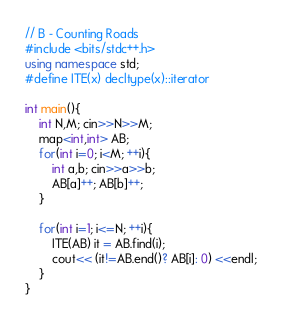Convert code to text. <code><loc_0><loc_0><loc_500><loc_500><_C++_>// B - Counting Roads
#include <bits/stdc++.h>
using namespace std;
#define ITE(x) decltype(x)::iterator

int main(){
	int N,M; cin>>N>>M;
	map<int,int> AB;
	for(int i=0; i<M; ++i){
		int a,b; cin>>a>>b;
		AB[a]++; AB[b]++;
	}

	for(int i=1; i<=N; ++i){
		ITE(AB) it = AB.find(i);
		cout<< (it!=AB.end()? AB[i]: 0) <<endl;
	}
}</code> 